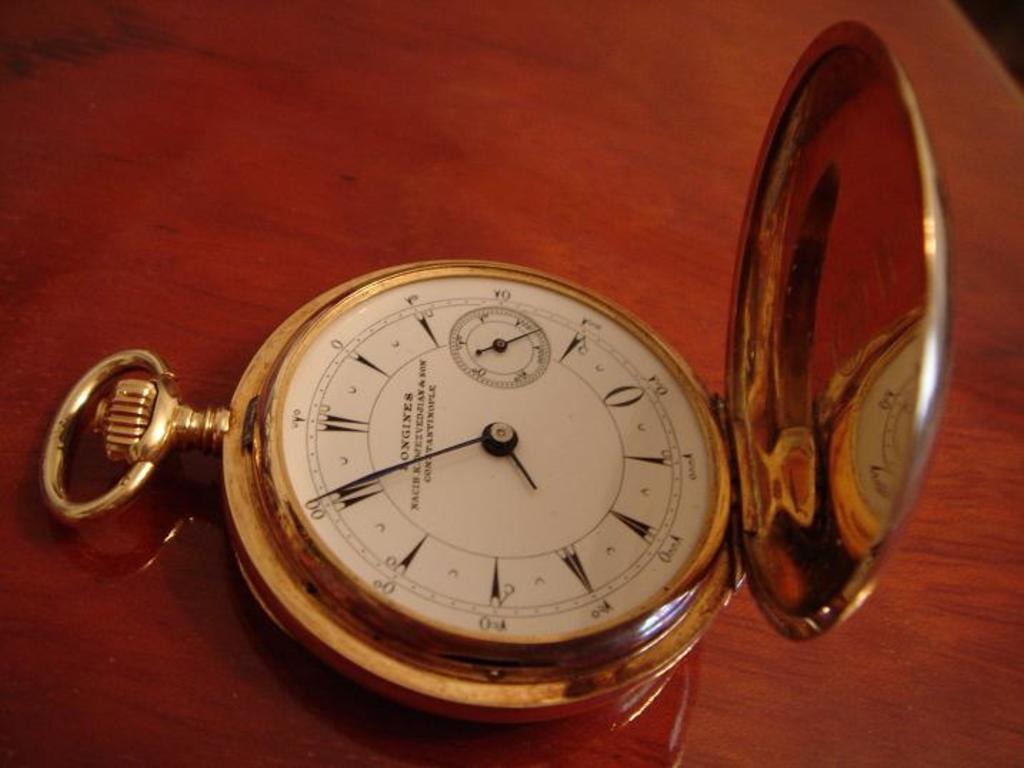What time is displayed on the watch?
Offer a terse response. 7:55. What color is the pocket watch?
Ensure brevity in your answer.  Gold. 